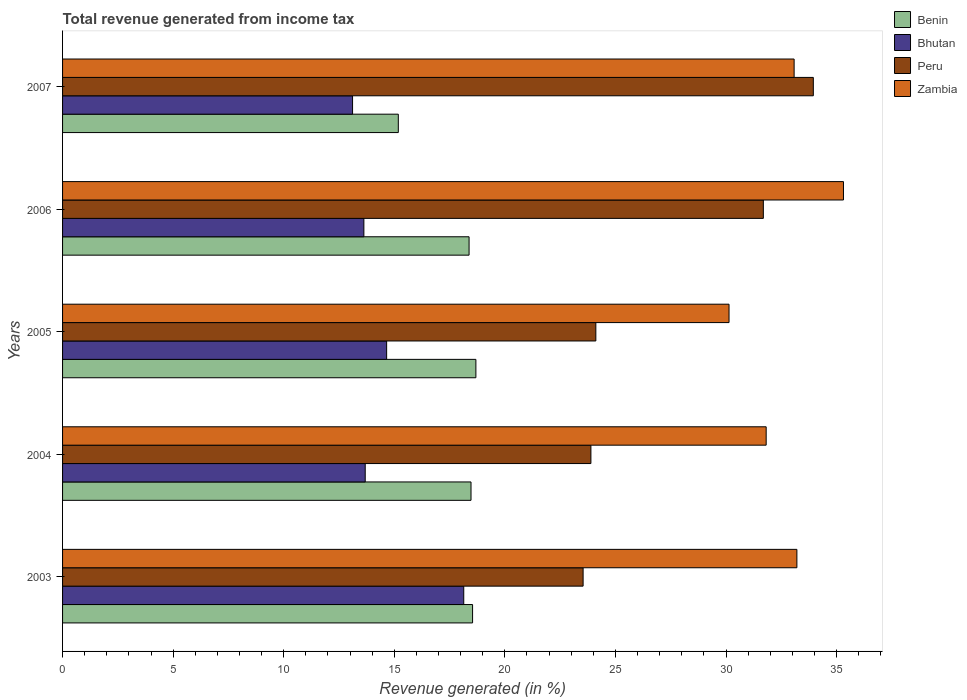How many groups of bars are there?
Provide a short and direct response. 5. Are the number of bars on each tick of the Y-axis equal?
Offer a very short reply. Yes. How many bars are there on the 4th tick from the bottom?
Offer a very short reply. 4. What is the total revenue generated in Zambia in 2004?
Offer a terse response. 31.82. Across all years, what is the maximum total revenue generated in Peru?
Offer a terse response. 33.95. Across all years, what is the minimum total revenue generated in Bhutan?
Your response must be concise. 13.11. What is the total total revenue generated in Zambia in the graph?
Make the answer very short. 163.55. What is the difference between the total revenue generated in Benin in 2003 and that in 2005?
Provide a succinct answer. -0.15. What is the difference between the total revenue generated in Peru in 2006 and the total revenue generated in Zambia in 2003?
Ensure brevity in your answer.  -1.52. What is the average total revenue generated in Zambia per year?
Ensure brevity in your answer.  32.71. In the year 2004, what is the difference between the total revenue generated in Bhutan and total revenue generated in Benin?
Offer a terse response. -4.78. In how many years, is the total revenue generated in Benin greater than 33 %?
Offer a terse response. 0. What is the ratio of the total revenue generated in Zambia in 2003 to that in 2007?
Provide a short and direct response. 1. Is the total revenue generated in Bhutan in 2003 less than that in 2005?
Keep it short and to the point. No. Is the difference between the total revenue generated in Bhutan in 2005 and 2006 greater than the difference between the total revenue generated in Benin in 2005 and 2006?
Offer a terse response. Yes. What is the difference between the highest and the second highest total revenue generated in Bhutan?
Your answer should be very brief. 3.49. What is the difference between the highest and the lowest total revenue generated in Peru?
Keep it short and to the point. 10.41. Is it the case that in every year, the sum of the total revenue generated in Bhutan and total revenue generated in Benin is greater than the sum of total revenue generated in Peru and total revenue generated in Zambia?
Ensure brevity in your answer.  No. What does the 1st bar from the top in 2006 represents?
Provide a short and direct response. Zambia. What does the 2nd bar from the bottom in 2004 represents?
Ensure brevity in your answer.  Bhutan. How many bars are there?
Keep it short and to the point. 20. How many years are there in the graph?
Provide a short and direct response. 5. What is the difference between two consecutive major ticks on the X-axis?
Give a very brief answer. 5. Are the values on the major ticks of X-axis written in scientific E-notation?
Offer a very short reply. No. Does the graph contain grids?
Your response must be concise. No. Where does the legend appear in the graph?
Provide a short and direct response. Top right. How many legend labels are there?
Your response must be concise. 4. What is the title of the graph?
Offer a very short reply. Total revenue generated from income tax. What is the label or title of the X-axis?
Keep it short and to the point. Revenue generated (in %). What is the label or title of the Y-axis?
Your response must be concise. Years. What is the Revenue generated (in %) of Benin in 2003?
Ensure brevity in your answer.  18.54. What is the Revenue generated (in %) of Bhutan in 2003?
Keep it short and to the point. 18.14. What is the Revenue generated (in %) of Peru in 2003?
Give a very brief answer. 23.54. What is the Revenue generated (in %) in Zambia in 2003?
Ensure brevity in your answer.  33.21. What is the Revenue generated (in %) in Benin in 2004?
Provide a succinct answer. 18.47. What is the Revenue generated (in %) of Bhutan in 2004?
Ensure brevity in your answer.  13.69. What is the Revenue generated (in %) in Peru in 2004?
Provide a short and direct response. 23.89. What is the Revenue generated (in %) in Zambia in 2004?
Ensure brevity in your answer.  31.82. What is the Revenue generated (in %) of Benin in 2005?
Provide a short and direct response. 18.69. What is the Revenue generated (in %) of Bhutan in 2005?
Your response must be concise. 14.65. What is the Revenue generated (in %) in Peru in 2005?
Your response must be concise. 24.11. What is the Revenue generated (in %) in Zambia in 2005?
Offer a very short reply. 30.14. What is the Revenue generated (in %) in Benin in 2006?
Offer a very short reply. 18.38. What is the Revenue generated (in %) in Bhutan in 2006?
Offer a terse response. 13.63. What is the Revenue generated (in %) of Peru in 2006?
Ensure brevity in your answer.  31.69. What is the Revenue generated (in %) of Zambia in 2006?
Your response must be concise. 35.31. What is the Revenue generated (in %) in Benin in 2007?
Offer a terse response. 15.18. What is the Revenue generated (in %) of Bhutan in 2007?
Your response must be concise. 13.11. What is the Revenue generated (in %) of Peru in 2007?
Provide a succinct answer. 33.95. What is the Revenue generated (in %) in Zambia in 2007?
Ensure brevity in your answer.  33.08. Across all years, what is the maximum Revenue generated (in %) in Benin?
Give a very brief answer. 18.69. Across all years, what is the maximum Revenue generated (in %) of Bhutan?
Keep it short and to the point. 18.14. Across all years, what is the maximum Revenue generated (in %) in Peru?
Offer a terse response. 33.95. Across all years, what is the maximum Revenue generated (in %) in Zambia?
Offer a terse response. 35.31. Across all years, what is the minimum Revenue generated (in %) in Benin?
Your answer should be very brief. 15.18. Across all years, what is the minimum Revenue generated (in %) of Bhutan?
Provide a short and direct response. 13.11. Across all years, what is the minimum Revenue generated (in %) of Peru?
Your answer should be very brief. 23.54. Across all years, what is the minimum Revenue generated (in %) in Zambia?
Make the answer very short. 30.14. What is the total Revenue generated (in %) of Benin in the graph?
Your answer should be very brief. 89.27. What is the total Revenue generated (in %) of Bhutan in the graph?
Offer a terse response. 73.22. What is the total Revenue generated (in %) of Peru in the graph?
Give a very brief answer. 137.18. What is the total Revenue generated (in %) of Zambia in the graph?
Your response must be concise. 163.55. What is the difference between the Revenue generated (in %) of Benin in 2003 and that in 2004?
Your response must be concise. 0.07. What is the difference between the Revenue generated (in %) of Bhutan in 2003 and that in 2004?
Provide a succinct answer. 4.46. What is the difference between the Revenue generated (in %) in Peru in 2003 and that in 2004?
Provide a short and direct response. -0.35. What is the difference between the Revenue generated (in %) of Zambia in 2003 and that in 2004?
Offer a terse response. 1.39. What is the difference between the Revenue generated (in %) in Benin in 2003 and that in 2005?
Provide a succinct answer. -0.15. What is the difference between the Revenue generated (in %) of Bhutan in 2003 and that in 2005?
Your answer should be very brief. 3.49. What is the difference between the Revenue generated (in %) in Peru in 2003 and that in 2005?
Provide a succinct answer. -0.58. What is the difference between the Revenue generated (in %) of Zambia in 2003 and that in 2005?
Make the answer very short. 3.07. What is the difference between the Revenue generated (in %) of Benin in 2003 and that in 2006?
Provide a short and direct response. 0.16. What is the difference between the Revenue generated (in %) of Bhutan in 2003 and that in 2006?
Ensure brevity in your answer.  4.52. What is the difference between the Revenue generated (in %) of Peru in 2003 and that in 2006?
Provide a short and direct response. -8.15. What is the difference between the Revenue generated (in %) in Zambia in 2003 and that in 2006?
Offer a terse response. -2.11. What is the difference between the Revenue generated (in %) in Benin in 2003 and that in 2007?
Offer a terse response. 3.36. What is the difference between the Revenue generated (in %) of Bhutan in 2003 and that in 2007?
Give a very brief answer. 5.03. What is the difference between the Revenue generated (in %) of Peru in 2003 and that in 2007?
Provide a short and direct response. -10.41. What is the difference between the Revenue generated (in %) of Zambia in 2003 and that in 2007?
Ensure brevity in your answer.  0.13. What is the difference between the Revenue generated (in %) of Benin in 2004 and that in 2005?
Provide a short and direct response. -0.22. What is the difference between the Revenue generated (in %) in Bhutan in 2004 and that in 2005?
Your answer should be compact. -0.97. What is the difference between the Revenue generated (in %) of Peru in 2004 and that in 2005?
Provide a short and direct response. -0.22. What is the difference between the Revenue generated (in %) of Zambia in 2004 and that in 2005?
Keep it short and to the point. 1.68. What is the difference between the Revenue generated (in %) of Benin in 2004 and that in 2006?
Your response must be concise. 0.09. What is the difference between the Revenue generated (in %) of Bhutan in 2004 and that in 2006?
Your response must be concise. 0.06. What is the difference between the Revenue generated (in %) in Peru in 2004 and that in 2006?
Offer a very short reply. -7.8. What is the difference between the Revenue generated (in %) of Zambia in 2004 and that in 2006?
Your answer should be compact. -3.5. What is the difference between the Revenue generated (in %) of Benin in 2004 and that in 2007?
Ensure brevity in your answer.  3.29. What is the difference between the Revenue generated (in %) in Bhutan in 2004 and that in 2007?
Offer a very short reply. 0.57. What is the difference between the Revenue generated (in %) of Peru in 2004 and that in 2007?
Your response must be concise. -10.06. What is the difference between the Revenue generated (in %) in Zambia in 2004 and that in 2007?
Give a very brief answer. -1.26. What is the difference between the Revenue generated (in %) of Benin in 2005 and that in 2006?
Offer a very short reply. 0.31. What is the difference between the Revenue generated (in %) of Bhutan in 2005 and that in 2006?
Offer a terse response. 1.03. What is the difference between the Revenue generated (in %) in Peru in 2005 and that in 2006?
Keep it short and to the point. -7.57. What is the difference between the Revenue generated (in %) in Zambia in 2005 and that in 2006?
Make the answer very short. -5.17. What is the difference between the Revenue generated (in %) in Benin in 2005 and that in 2007?
Make the answer very short. 3.51. What is the difference between the Revenue generated (in %) of Bhutan in 2005 and that in 2007?
Offer a very short reply. 1.54. What is the difference between the Revenue generated (in %) in Peru in 2005 and that in 2007?
Make the answer very short. -9.83. What is the difference between the Revenue generated (in %) in Zambia in 2005 and that in 2007?
Your answer should be compact. -2.94. What is the difference between the Revenue generated (in %) in Benin in 2006 and that in 2007?
Ensure brevity in your answer.  3.2. What is the difference between the Revenue generated (in %) in Bhutan in 2006 and that in 2007?
Make the answer very short. 0.51. What is the difference between the Revenue generated (in %) of Peru in 2006 and that in 2007?
Provide a succinct answer. -2.26. What is the difference between the Revenue generated (in %) of Zambia in 2006 and that in 2007?
Your answer should be compact. 2.23. What is the difference between the Revenue generated (in %) of Benin in 2003 and the Revenue generated (in %) of Bhutan in 2004?
Provide a succinct answer. 4.85. What is the difference between the Revenue generated (in %) of Benin in 2003 and the Revenue generated (in %) of Peru in 2004?
Ensure brevity in your answer.  -5.35. What is the difference between the Revenue generated (in %) of Benin in 2003 and the Revenue generated (in %) of Zambia in 2004?
Ensure brevity in your answer.  -13.28. What is the difference between the Revenue generated (in %) of Bhutan in 2003 and the Revenue generated (in %) of Peru in 2004?
Your answer should be compact. -5.75. What is the difference between the Revenue generated (in %) in Bhutan in 2003 and the Revenue generated (in %) in Zambia in 2004?
Ensure brevity in your answer.  -13.68. What is the difference between the Revenue generated (in %) in Peru in 2003 and the Revenue generated (in %) in Zambia in 2004?
Your answer should be very brief. -8.28. What is the difference between the Revenue generated (in %) of Benin in 2003 and the Revenue generated (in %) of Bhutan in 2005?
Ensure brevity in your answer.  3.89. What is the difference between the Revenue generated (in %) in Benin in 2003 and the Revenue generated (in %) in Peru in 2005?
Offer a very short reply. -5.57. What is the difference between the Revenue generated (in %) in Benin in 2003 and the Revenue generated (in %) in Zambia in 2005?
Keep it short and to the point. -11.6. What is the difference between the Revenue generated (in %) in Bhutan in 2003 and the Revenue generated (in %) in Peru in 2005?
Your answer should be very brief. -5.97. What is the difference between the Revenue generated (in %) in Bhutan in 2003 and the Revenue generated (in %) in Zambia in 2005?
Your answer should be compact. -12. What is the difference between the Revenue generated (in %) of Peru in 2003 and the Revenue generated (in %) of Zambia in 2005?
Your answer should be compact. -6.6. What is the difference between the Revenue generated (in %) of Benin in 2003 and the Revenue generated (in %) of Bhutan in 2006?
Provide a short and direct response. 4.92. What is the difference between the Revenue generated (in %) in Benin in 2003 and the Revenue generated (in %) in Peru in 2006?
Your answer should be compact. -13.15. What is the difference between the Revenue generated (in %) of Benin in 2003 and the Revenue generated (in %) of Zambia in 2006?
Keep it short and to the point. -16.77. What is the difference between the Revenue generated (in %) in Bhutan in 2003 and the Revenue generated (in %) in Peru in 2006?
Keep it short and to the point. -13.55. What is the difference between the Revenue generated (in %) of Bhutan in 2003 and the Revenue generated (in %) of Zambia in 2006?
Provide a succinct answer. -17.17. What is the difference between the Revenue generated (in %) of Peru in 2003 and the Revenue generated (in %) of Zambia in 2006?
Provide a succinct answer. -11.77. What is the difference between the Revenue generated (in %) in Benin in 2003 and the Revenue generated (in %) in Bhutan in 2007?
Keep it short and to the point. 5.43. What is the difference between the Revenue generated (in %) in Benin in 2003 and the Revenue generated (in %) in Peru in 2007?
Offer a very short reply. -15.41. What is the difference between the Revenue generated (in %) in Benin in 2003 and the Revenue generated (in %) in Zambia in 2007?
Offer a very short reply. -14.54. What is the difference between the Revenue generated (in %) of Bhutan in 2003 and the Revenue generated (in %) of Peru in 2007?
Provide a short and direct response. -15.81. What is the difference between the Revenue generated (in %) in Bhutan in 2003 and the Revenue generated (in %) in Zambia in 2007?
Offer a very short reply. -14.94. What is the difference between the Revenue generated (in %) in Peru in 2003 and the Revenue generated (in %) in Zambia in 2007?
Provide a succinct answer. -9.54. What is the difference between the Revenue generated (in %) of Benin in 2004 and the Revenue generated (in %) of Bhutan in 2005?
Your answer should be compact. 3.82. What is the difference between the Revenue generated (in %) of Benin in 2004 and the Revenue generated (in %) of Peru in 2005?
Your answer should be compact. -5.64. What is the difference between the Revenue generated (in %) of Benin in 2004 and the Revenue generated (in %) of Zambia in 2005?
Your answer should be compact. -11.67. What is the difference between the Revenue generated (in %) in Bhutan in 2004 and the Revenue generated (in %) in Peru in 2005?
Your response must be concise. -10.43. What is the difference between the Revenue generated (in %) in Bhutan in 2004 and the Revenue generated (in %) in Zambia in 2005?
Ensure brevity in your answer.  -16.45. What is the difference between the Revenue generated (in %) in Peru in 2004 and the Revenue generated (in %) in Zambia in 2005?
Ensure brevity in your answer.  -6.25. What is the difference between the Revenue generated (in %) of Benin in 2004 and the Revenue generated (in %) of Bhutan in 2006?
Your answer should be very brief. 4.84. What is the difference between the Revenue generated (in %) in Benin in 2004 and the Revenue generated (in %) in Peru in 2006?
Provide a succinct answer. -13.22. What is the difference between the Revenue generated (in %) of Benin in 2004 and the Revenue generated (in %) of Zambia in 2006?
Make the answer very short. -16.84. What is the difference between the Revenue generated (in %) in Bhutan in 2004 and the Revenue generated (in %) in Peru in 2006?
Offer a very short reply. -18. What is the difference between the Revenue generated (in %) in Bhutan in 2004 and the Revenue generated (in %) in Zambia in 2006?
Offer a terse response. -21.63. What is the difference between the Revenue generated (in %) of Peru in 2004 and the Revenue generated (in %) of Zambia in 2006?
Your response must be concise. -11.42. What is the difference between the Revenue generated (in %) of Benin in 2004 and the Revenue generated (in %) of Bhutan in 2007?
Your answer should be compact. 5.36. What is the difference between the Revenue generated (in %) of Benin in 2004 and the Revenue generated (in %) of Peru in 2007?
Ensure brevity in your answer.  -15.48. What is the difference between the Revenue generated (in %) in Benin in 2004 and the Revenue generated (in %) in Zambia in 2007?
Your answer should be very brief. -14.61. What is the difference between the Revenue generated (in %) in Bhutan in 2004 and the Revenue generated (in %) in Peru in 2007?
Ensure brevity in your answer.  -20.26. What is the difference between the Revenue generated (in %) in Bhutan in 2004 and the Revenue generated (in %) in Zambia in 2007?
Provide a short and direct response. -19.39. What is the difference between the Revenue generated (in %) of Peru in 2004 and the Revenue generated (in %) of Zambia in 2007?
Offer a terse response. -9.19. What is the difference between the Revenue generated (in %) in Benin in 2005 and the Revenue generated (in %) in Bhutan in 2006?
Make the answer very short. 5.07. What is the difference between the Revenue generated (in %) of Benin in 2005 and the Revenue generated (in %) of Peru in 2006?
Offer a very short reply. -13. What is the difference between the Revenue generated (in %) of Benin in 2005 and the Revenue generated (in %) of Zambia in 2006?
Your response must be concise. -16.62. What is the difference between the Revenue generated (in %) of Bhutan in 2005 and the Revenue generated (in %) of Peru in 2006?
Keep it short and to the point. -17.03. What is the difference between the Revenue generated (in %) in Bhutan in 2005 and the Revenue generated (in %) in Zambia in 2006?
Your answer should be compact. -20.66. What is the difference between the Revenue generated (in %) of Peru in 2005 and the Revenue generated (in %) of Zambia in 2006?
Your response must be concise. -11.2. What is the difference between the Revenue generated (in %) in Benin in 2005 and the Revenue generated (in %) in Bhutan in 2007?
Offer a terse response. 5.58. What is the difference between the Revenue generated (in %) in Benin in 2005 and the Revenue generated (in %) in Peru in 2007?
Ensure brevity in your answer.  -15.26. What is the difference between the Revenue generated (in %) of Benin in 2005 and the Revenue generated (in %) of Zambia in 2007?
Offer a very short reply. -14.39. What is the difference between the Revenue generated (in %) of Bhutan in 2005 and the Revenue generated (in %) of Peru in 2007?
Provide a succinct answer. -19.29. What is the difference between the Revenue generated (in %) in Bhutan in 2005 and the Revenue generated (in %) in Zambia in 2007?
Provide a short and direct response. -18.43. What is the difference between the Revenue generated (in %) of Peru in 2005 and the Revenue generated (in %) of Zambia in 2007?
Your response must be concise. -8.97. What is the difference between the Revenue generated (in %) in Benin in 2006 and the Revenue generated (in %) in Bhutan in 2007?
Provide a succinct answer. 5.27. What is the difference between the Revenue generated (in %) of Benin in 2006 and the Revenue generated (in %) of Peru in 2007?
Your answer should be compact. -15.57. What is the difference between the Revenue generated (in %) in Benin in 2006 and the Revenue generated (in %) in Zambia in 2007?
Offer a terse response. -14.7. What is the difference between the Revenue generated (in %) in Bhutan in 2006 and the Revenue generated (in %) in Peru in 2007?
Your answer should be compact. -20.32. What is the difference between the Revenue generated (in %) in Bhutan in 2006 and the Revenue generated (in %) in Zambia in 2007?
Ensure brevity in your answer.  -19.46. What is the difference between the Revenue generated (in %) of Peru in 2006 and the Revenue generated (in %) of Zambia in 2007?
Give a very brief answer. -1.39. What is the average Revenue generated (in %) in Benin per year?
Your answer should be compact. 17.85. What is the average Revenue generated (in %) of Bhutan per year?
Your answer should be compact. 14.64. What is the average Revenue generated (in %) in Peru per year?
Provide a short and direct response. 27.44. What is the average Revenue generated (in %) in Zambia per year?
Offer a very short reply. 32.71. In the year 2003, what is the difference between the Revenue generated (in %) of Benin and Revenue generated (in %) of Bhutan?
Your answer should be compact. 0.4. In the year 2003, what is the difference between the Revenue generated (in %) of Benin and Revenue generated (in %) of Peru?
Offer a very short reply. -5. In the year 2003, what is the difference between the Revenue generated (in %) in Benin and Revenue generated (in %) in Zambia?
Offer a terse response. -14.67. In the year 2003, what is the difference between the Revenue generated (in %) in Bhutan and Revenue generated (in %) in Peru?
Your answer should be compact. -5.4. In the year 2003, what is the difference between the Revenue generated (in %) in Bhutan and Revenue generated (in %) in Zambia?
Give a very brief answer. -15.06. In the year 2003, what is the difference between the Revenue generated (in %) in Peru and Revenue generated (in %) in Zambia?
Provide a succinct answer. -9.67. In the year 2004, what is the difference between the Revenue generated (in %) of Benin and Revenue generated (in %) of Bhutan?
Provide a succinct answer. 4.78. In the year 2004, what is the difference between the Revenue generated (in %) of Benin and Revenue generated (in %) of Peru?
Keep it short and to the point. -5.42. In the year 2004, what is the difference between the Revenue generated (in %) of Benin and Revenue generated (in %) of Zambia?
Make the answer very short. -13.35. In the year 2004, what is the difference between the Revenue generated (in %) of Bhutan and Revenue generated (in %) of Peru?
Your answer should be compact. -10.21. In the year 2004, what is the difference between the Revenue generated (in %) in Bhutan and Revenue generated (in %) in Zambia?
Your answer should be compact. -18.13. In the year 2004, what is the difference between the Revenue generated (in %) in Peru and Revenue generated (in %) in Zambia?
Provide a short and direct response. -7.93. In the year 2005, what is the difference between the Revenue generated (in %) of Benin and Revenue generated (in %) of Bhutan?
Your answer should be very brief. 4.04. In the year 2005, what is the difference between the Revenue generated (in %) of Benin and Revenue generated (in %) of Peru?
Your response must be concise. -5.42. In the year 2005, what is the difference between the Revenue generated (in %) of Benin and Revenue generated (in %) of Zambia?
Your response must be concise. -11.45. In the year 2005, what is the difference between the Revenue generated (in %) in Bhutan and Revenue generated (in %) in Peru?
Give a very brief answer. -9.46. In the year 2005, what is the difference between the Revenue generated (in %) of Bhutan and Revenue generated (in %) of Zambia?
Make the answer very short. -15.48. In the year 2005, what is the difference between the Revenue generated (in %) of Peru and Revenue generated (in %) of Zambia?
Your answer should be compact. -6.02. In the year 2006, what is the difference between the Revenue generated (in %) in Benin and Revenue generated (in %) in Bhutan?
Keep it short and to the point. 4.76. In the year 2006, what is the difference between the Revenue generated (in %) in Benin and Revenue generated (in %) in Peru?
Make the answer very short. -13.31. In the year 2006, what is the difference between the Revenue generated (in %) in Benin and Revenue generated (in %) in Zambia?
Your answer should be compact. -16.93. In the year 2006, what is the difference between the Revenue generated (in %) of Bhutan and Revenue generated (in %) of Peru?
Your answer should be very brief. -18.06. In the year 2006, what is the difference between the Revenue generated (in %) in Bhutan and Revenue generated (in %) in Zambia?
Keep it short and to the point. -21.69. In the year 2006, what is the difference between the Revenue generated (in %) of Peru and Revenue generated (in %) of Zambia?
Provide a short and direct response. -3.62. In the year 2007, what is the difference between the Revenue generated (in %) of Benin and Revenue generated (in %) of Bhutan?
Your response must be concise. 2.07. In the year 2007, what is the difference between the Revenue generated (in %) in Benin and Revenue generated (in %) in Peru?
Make the answer very short. -18.77. In the year 2007, what is the difference between the Revenue generated (in %) in Benin and Revenue generated (in %) in Zambia?
Your response must be concise. -17.9. In the year 2007, what is the difference between the Revenue generated (in %) of Bhutan and Revenue generated (in %) of Peru?
Offer a terse response. -20.84. In the year 2007, what is the difference between the Revenue generated (in %) in Bhutan and Revenue generated (in %) in Zambia?
Your response must be concise. -19.97. In the year 2007, what is the difference between the Revenue generated (in %) of Peru and Revenue generated (in %) of Zambia?
Keep it short and to the point. 0.87. What is the ratio of the Revenue generated (in %) of Benin in 2003 to that in 2004?
Offer a terse response. 1. What is the ratio of the Revenue generated (in %) of Bhutan in 2003 to that in 2004?
Give a very brief answer. 1.33. What is the ratio of the Revenue generated (in %) of Zambia in 2003 to that in 2004?
Give a very brief answer. 1.04. What is the ratio of the Revenue generated (in %) in Bhutan in 2003 to that in 2005?
Offer a very short reply. 1.24. What is the ratio of the Revenue generated (in %) of Peru in 2003 to that in 2005?
Ensure brevity in your answer.  0.98. What is the ratio of the Revenue generated (in %) in Zambia in 2003 to that in 2005?
Ensure brevity in your answer.  1.1. What is the ratio of the Revenue generated (in %) in Benin in 2003 to that in 2006?
Give a very brief answer. 1.01. What is the ratio of the Revenue generated (in %) in Bhutan in 2003 to that in 2006?
Offer a very short reply. 1.33. What is the ratio of the Revenue generated (in %) in Peru in 2003 to that in 2006?
Offer a very short reply. 0.74. What is the ratio of the Revenue generated (in %) in Zambia in 2003 to that in 2006?
Provide a short and direct response. 0.94. What is the ratio of the Revenue generated (in %) of Benin in 2003 to that in 2007?
Your answer should be compact. 1.22. What is the ratio of the Revenue generated (in %) of Bhutan in 2003 to that in 2007?
Offer a very short reply. 1.38. What is the ratio of the Revenue generated (in %) of Peru in 2003 to that in 2007?
Offer a very short reply. 0.69. What is the ratio of the Revenue generated (in %) in Zambia in 2003 to that in 2007?
Provide a short and direct response. 1. What is the ratio of the Revenue generated (in %) in Benin in 2004 to that in 2005?
Keep it short and to the point. 0.99. What is the ratio of the Revenue generated (in %) of Bhutan in 2004 to that in 2005?
Offer a very short reply. 0.93. What is the ratio of the Revenue generated (in %) of Peru in 2004 to that in 2005?
Ensure brevity in your answer.  0.99. What is the ratio of the Revenue generated (in %) of Zambia in 2004 to that in 2005?
Provide a short and direct response. 1.06. What is the ratio of the Revenue generated (in %) of Benin in 2004 to that in 2006?
Keep it short and to the point. 1. What is the ratio of the Revenue generated (in %) of Peru in 2004 to that in 2006?
Offer a very short reply. 0.75. What is the ratio of the Revenue generated (in %) in Zambia in 2004 to that in 2006?
Give a very brief answer. 0.9. What is the ratio of the Revenue generated (in %) in Benin in 2004 to that in 2007?
Make the answer very short. 1.22. What is the ratio of the Revenue generated (in %) in Bhutan in 2004 to that in 2007?
Keep it short and to the point. 1.04. What is the ratio of the Revenue generated (in %) of Peru in 2004 to that in 2007?
Offer a terse response. 0.7. What is the ratio of the Revenue generated (in %) in Zambia in 2004 to that in 2007?
Ensure brevity in your answer.  0.96. What is the ratio of the Revenue generated (in %) of Benin in 2005 to that in 2006?
Provide a short and direct response. 1.02. What is the ratio of the Revenue generated (in %) of Bhutan in 2005 to that in 2006?
Offer a terse response. 1.08. What is the ratio of the Revenue generated (in %) in Peru in 2005 to that in 2006?
Keep it short and to the point. 0.76. What is the ratio of the Revenue generated (in %) in Zambia in 2005 to that in 2006?
Provide a succinct answer. 0.85. What is the ratio of the Revenue generated (in %) in Benin in 2005 to that in 2007?
Provide a short and direct response. 1.23. What is the ratio of the Revenue generated (in %) of Bhutan in 2005 to that in 2007?
Make the answer very short. 1.12. What is the ratio of the Revenue generated (in %) in Peru in 2005 to that in 2007?
Give a very brief answer. 0.71. What is the ratio of the Revenue generated (in %) of Zambia in 2005 to that in 2007?
Give a very brief answer. 0.91. What is the ratio of the Revenue generated (in %) in Benin in 2006 to that in 2007?
Provide a short and direct response. 1.21. What is the ratio of the Revenue generated (in %) of Bhutan in 2006 to that in 2007?
Your response must be concise. 1.04. What is the ratio of the Revenue generated (in %) in Peru in 2006 to that in 2007?
Keep it short and to the point. 0.93. What is the ratio of the Revenue generated (in %) of Zambia in 2006 to that in 2007?
Give a very brief answer. 1.07. What is the difference between the highest and the second highest Revenue generated (in %) in Benin?
Your response must be concise. 0.15. What is the difference between the highest and the second highest Revenue generated (in %) of Bhutan?
Your answer should be very brief. 3.49. What is the difference between the highest and the second highest Revenue generated (in %) in Peru?
Offer a very short reply. 2.26. What is the difference between the highest and the second highest Revenue generated (in %) of Zambia?
Your answer should be compact. 2.11. What is the difference between the highest and the lowest Revenue generated (in %) of Benin?
Offer a terse response. 3.51. What is the difference between the highest and the lowest Revenue generated (in %) of Bhutan?
Keep it short and to the point. 5.03. What is the difference between the highest and the lowest Revenue generated (in %) in Peru?
Your answer should be compact. 10.41. What is the difference between the highest and the lowest Revenue generated (in %) of Zambia?
Provide a succinct answer. 5.17. 